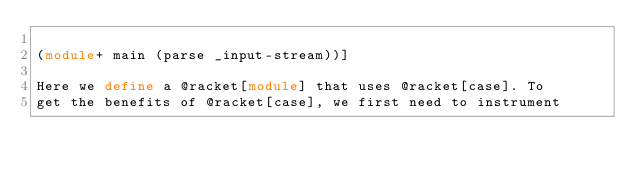Convert code to text. <code><loc_0><loc_0><loc_500><loc_500><_Racket_>
(module+ main (parse _input-stream))]

Here we define a @racket[module] that uses @racket[case]. To
get the benefits of @racket[case], we first need to instrument</code> 